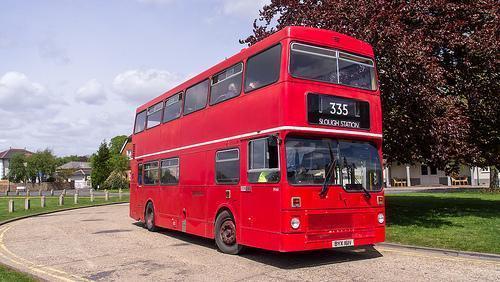How many stories is the bus?
Give a very brief answer. 2. 